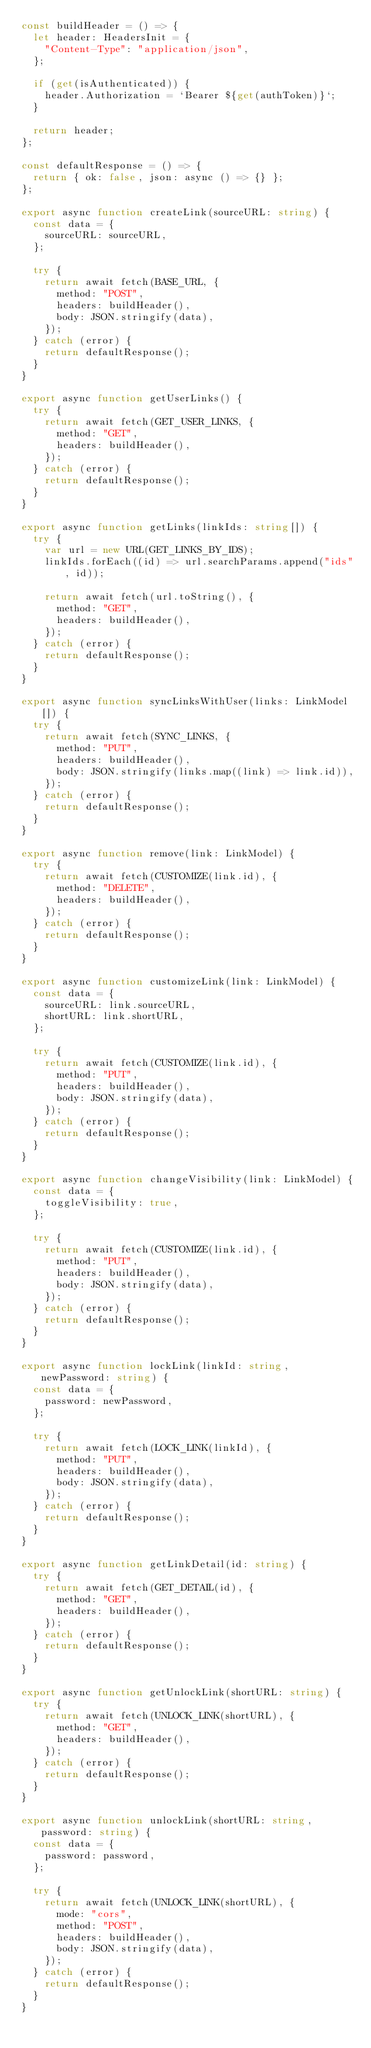<code> <loc_0><loc_0><loc_500><loc_500><_TypeScript_>const buildHeader = () => {
  let header: HeadersInit = {
    "Content-Type": "application/json",
  };

  if (get(isAuthenticated)) {
    header.Authorization = `Bearer ${get(authToken)}`;
  }

  return header;
};

const defaultResponse = () => {
  return { ok: false, json: async () => {} };
};

export async function createLink(sourceURL: string) {
  const data = {
    sourceURL: sourceURL,
  };

  try {
    return await fetch(BASE_URL, {
      method: "POST",
      headers: buildHeader(),
      body: JSON.stringify(data),
    });
  } catch (error) {
    return defaultResponse();
  }
}

export async function getUserLinks() {
  try {
    return await fetch(GET_USER_LINKS, {
      method: "GET",
      headers: buildHeader(),
    });
  } catch (error) {
    return defaultResponse();
  }
}

export async function getLinks(linkIds: string[]) {
  try {
    var url = new URL(GET_LINKS_BY_IDS);
    linkIds.forEach((id) => url.searchParams.append("ids", id));

    return await fetch(url.toString(), {
      method: "GET",
      headers: buildHeader(),
    });
  } catch (error) {
    return defaultResponse();
  }
}

export async function syncLinksWithUser(links: LinkModel[]) {
  try {
    return await fetch(SYNC_LINKS, {
      method: "PUT",
      headers: buildHeader(),
      body: JSON.stringify(links.map((link) => link.id)),
    });
  } catch (error) {
    return defaultResponse();
  }
}

export async function remove(link: LinkModel) {
  try {
    return await fetch(CUSTOMIZE(link.id), {
      method: "DELETE",
      headers: buildHeader(),
    });
  } catch (error) {
    return defaultResponse();
  }
}

export async function customizeLink(link: LinkModel) {
  const data = {
    sourceURL: link.sourceURL,
    shortURL: link.shortURL,
  };

  try {
    return await fetch(CUSTOMIZE(link.id), {
      method: "PUT",
      headers: buildHeader(),
      body: JSON.stringify(data),
    });
  } catch (error) {
    return defaultResponse();
  }
}

export async function changeVisibility(link: LinkModel) {
  const data = {
    toggleVisibility: true,
  };

  try {
    return await fetch(CUSTOMIZE(link.id), {
      method: "PUT",
      headers: buildHeader(),
      body: JSON.stringify(data),
    });
  } catch (error) {
    return defaultResponse();
  }
}

export async function lockLink(linkId: string, newPassword: string) {
  const data = {
    password: newPassword,
  };

  try {
    return await fetch(LOCK_LINK(linkId), {
      method: "PUT",
      headers: buildHeader(),
      body: JSON.stringify(data),
    });
  } catch (error) {
    return defaultResponse();
  }
}

export async function getLinkDetail(id: string) {
  try {
    return await fetch(GET_DETAIL(id), {
      method: "GET",
      headers: buildHeader(),
    });
  } catch (error) {
    return defaultResponse();
  }
}

export async function getUnlockLink(shortURL: string) {
  try {
    return await fetch(UNLOCK_LINK(shortURL), {
      method: "GET",
      headers: buildHeader(),
    });
  } catch (error) {
    return defaultResponse();
  }
}

export async function unlockLink(shortURL: string, password: string) {
  const data = {
    password: password,
  };

  try {
    return await fetch(UNLOCK_LINK(shortURL), {
      mode: "cors",
      method: "POST",
      headers: buildHeader(),
      body: JSON.stringify(data),
    });
  } catch (error) {
    return defaultResponse();
  }
}
</code> 